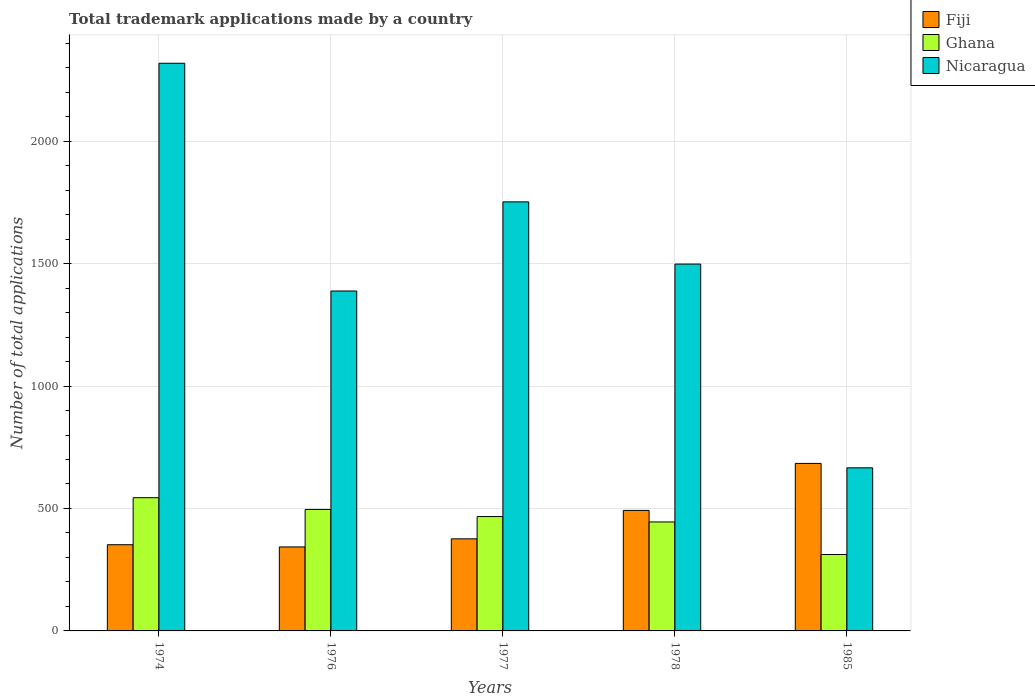How many groups of bars are there?
Ensure brevity in your answer.  5. Are the number of bars on each tick of the X-axis equal?
Offer a terse response. Yes. How many bars are there on the 4th tick from the left?
Ensure brevity in your answer.  3. What is the label of the 2nd group of bars from the left?
Offer a terse response. 1976. What is the number of applications made by in Ghana in 1974?
Your response must be concise. 544. Across all years, what is the maximum number of applications made by in Ghana?
Offer a terse response. 544. Across all years, what is the minimum number of applications made by in Ghana?
Provide a succinct answer. 312. In which year was the number of applications made by in Nicaragua maximum?
Offer a terse response. 1974. What is the total number of applications made by in Ghana in the graph?
Your answer should be compact. 2264. What is the difference between the number of applications made by in Nicaragua in 1974 and that in 1977?
Your response must be concise. 566. What is the difference between the number of applications made by in Fiji in 1976 and the number of applications made by in Ghana in 1974?
Your response must be concise. -201. What is the average number of applications made by in Fiji per year?
Offer a very short reply. 449.4. In the year 1977, what is the difference between the number of applications made by in Ghana and number of applications made by in Fiji?
Provide a short and direct response. 91. In how many years, is the number of applications made by in Nicaragua greater than 1700?
Offer a very short reply. 2. What is the ratio of the number of applications made by in Fiji in 1974 to that in 1985?
Offer a terse response. 0.51. Is the number of applications made by in Fiji in 1974 less than that in 1977?
Give a very brief answer. Yes. Is the difference between the number of applications made by in Ghana in 1976 and 1985 greater than the difference between the number of applications made by in Fiji in 1976 and 1985?
Offer a very short reply. Yes. What is the difference between the highest and the second highest number of applications made by in Ghana?
Offer a very short reply. 48. What is the difference between the highest and the lowest number of applications made by in Fiji?
Your answer should be very brief. 341. In how many years, is the number of applications made by in Nicaragua greater than the average number of applications made by in Nicaragua taken over all years?
Make the answer very short. 2. Is the sum of the number of applications made by in Ghana in 1977 and 1985 greater than the maximum number of applications made by in Fiji across all years?
Provide a succinct answer. Yes. What does the 1st bar from the right in 1977 represents?
Provide a succinct answer. Nicaragua. How many years are there in the graph?
Offer a terse response. 5. What is the difference between two consecutive major ticks on the Y-axis?
Make the answer very short. 500. Does the graph contain any zero values?
Ensure brevity in your answer.  No. How many legend labels are there?
Make the answer very short. 3. What is the title of the graph?
Your response must be concise. Total trademark applications made by a country. What is the label or title of the Y-axis?
Your answer should be very brief. Number of total applications. What is the Number of total applications in Fiji in 1974?
Your answer should be very brief. 352. What is the Number of total applications of Ghana in 1974?
Your answer should be compact. 544. What is the Number of total applications of Nicaragua in 1974?
Your answer should be compact. 2318. What is the Number of total applications of Fiji in 1976?
Your answer should be very brief. 343. What is the Number of total applications of Ghana in 1976?
Provide a short and direct response. 496. What is the Number of total applications of Nicaragua in 1976?
Offer a very short reply. 1388. What is the Number of total applications of Fiji in 1977?
Provide a succinct answer. 376. What is the Number of total applications of Ghana in 1977?
Give a very brief answer. 467. What is the Number of total applications in Nicaragua in 1977?
Offer a terse response. 1752. What is the Number of total applications of Fiji in 1978?
Provide a short and direct response. 492. What is the Number of total applications of Ghana in 1978?
Your answer should be compact. 445. What is the Number of total applications of Nicaragua in 1978?
Offer a very short reply. 1498. What is the Number of total applications in Fiji in 1985?
Provide a short and direct response. 684. What is the Number of total applications of Ghana in 1985?
Keep it short and to the point. 312. What is the Number of total applications in Nicaragua in 1985?
Provide a succinct answer. 666. Across all years, what is the maximum Number of total applications in Fiji?
Provide a short and direct response. 684. Across all years, what is the maximum Number of total applications in Ghana?
Offer a terse response. 544. Across all years, what is the maximum Number of total applications of Nicaragua?
Offer a very short reply. 2318. Across all years, what is the minimum Number of total applications in Fiji?
Your response must be concise. 343. Across all years, what is the minimum Number of total applications of Ghana?
Your response must be concise. 312. Across all years, what is the minimum Number of total applications in Nicaragua?
Your response must be concise. 666. What is the total Number of total applications of Fiji in the graph?
Your answer should be very brief. 2247. What is the total Number of total applications in Ghana in the graph?
Your answer should be very brief. 2264. What is the total Number of total applications in Nicaragua in the graph?
Your answer should be compact. 7622. What is the difference between the Number of total applications of Ghana in 1974 and that in 1976?
Ensure brevity in your answer.  48. What is the difference between the Number of total applications of Nicaragua in 1974 and that in 1976?
Your answer should be very brief. 930. What is the difference between the Number of total applications in Fiji in 1974 and that in 1977?
Offer a terse response. -24. What is the difference between the Number of total applications of Nicaragua in 1974 and that in 1977?
Ensure brevity in your answer.  566. What is the difference between the Number of total applications of Fiji in 1974 and that in 1978?
Give a very brief answer. -140. What is the difference between the Number of total applications of Ghana in 1974 and that in 1978?
Ensure brevity in your answer.  99. What is the difference between the Number of total applications of Nicaragua in 1974 and that in 1978?
Offer a very short reply. 820. What is the difference between the Number of total applications of Fiji in 1974 and that in 1985?
Your answer should be very brief. -332. What is the difference between the Number of total applications of Ghana in 1974 and that in 1985?
Provide a short and direct response. 232. What is the difference between the Number of total applications of Nicaragua in 1974 and that in 1985?
Offer a very short reply. 1652. What is the difference between the Number of total applications of Fiji in 1976 and that in 1977?
Provide a succinct answer. -33. What is the difference between the Number of total applications in Ghana in 1976 and that in 1977?
Ensure brevity in your answer.  29. What is the difference between the Number of total applications of Nicaragua in 1976 and that in 1977?
Ensure brevity in your answer.  -364. What is the difference between the Number of total applications in Fiji in 1976 and that in 1978?
Offer a very short reply. -149. What is the difference between the Number of total applications of Nicaragua in 1976 and that in 1978?
Your answer should be compact. -110. What is the difference between the Number of total applications of Fiji in 1976 and that in 1985?
Your answer should be compact. -341. What is the difference between the Number of total applications of Ghana in 1976 and that in 1985?
Your response must be concise. 184. What is the difference between the Number of total applications in Nicaragua in 1976 and that in 1985?
Keep it short and to the point. 722. What is the difference between the Number of total applications of Fiji in 1977 and that in 1978?
Offer a very short reply. -116. What is the difference between the Number of total applications in Nicaragua in 1977 and that in 1978?
Provide a succinct answer. 254. What is the difference between the Number of total applications of Fiji in 1977 and that in 1985?
Provide a short and direct response. -308. What is the difference between the Number of total applications of Ghana in 1977 and that in 1985?
Ensure brevity in your answer.  155. What is the difference between the Number of total applications of Nicaragua in 1977 and that in 1985?
Make the answer very short. 1086. What is the difference between the Number of total applications in Fiji in 1978 and that in 1985?
Keep it short and to the point. -192. What is the difference between the Number of total applications of Ghana in 1978 and that in 1985?
Provide a short and direct response. 133. What is the difference between the Number of total applications in Nicaragua in 1978 and that in 1985?
Provide a succinct answer. 832. What is the difference between the Number of total applications of Fiji in 1974 and the Number of total applications of Ghana in 1976?
Offer a terse response. -144. What is the difference between the Number of total applications of Fiji in 1974 and the Number of total applications of Nicaragua in 1976?
Make the answer very short. -1036. What is the difference between the Number of total applications of Ghana in 1974 and the Number of total applications of Nicaragua in 1976?
Keep it short and to the point. -844. What is the difference between the Number of total applications in Fiji in 1974 and the Number of total applications in Ghana in 1977?
Your answer should be compact. -115. What is the difference between the Number of total applications of Fiji in 1974 and the Number of total applications of Nicaragua in 1977?
Your answer should be compact. -1400. What is the difference between the Number of total applications of Ghana in 1974 and the Number of total applications of Nicaragua in 1977?
Provide a succinct answer. -1208. What is the difference between the Number of total applications of Fiji in 1974 and the Number of total applications of Ghana in 1978?
Your response must be concise. -93. What is the difference between the Number of total applications of Fiji in 1974 and the Number of total applications of Nicaragua in 1978?
Offer a very short reply. -1146. What is the difference between the Number of total applications of Ghana in 1974 and the Number of total applications of Nicaragua in 1978?
Give a very brief answer. -954. What is the difference between the Number of total applications in Fiji in 1974 and the Number of total applications in Ghana in 1985?
Your answer should be very brief. 40. What is the difference between the Number of total applications of Fiji in 1974 and the Number of total applications of Nicaragua in 1985?
Your answer should be very brief. -314. What is the difference between the Number of total applications in Ghana in 1974 and the Number of total applications in Nicaragua in 1985?
Provide a succinct answer. -122. What is the difference between the Number of total applications in Fiji in 1976 and the Number of total applications in Ghana in 1977?
Keep it short and to the point. -124. What is the difference between the Number of total applications in Fiji in 1976 and the Number of total applications in Nicaragua in 1977?
Your response must be concise. -1409. What is the difference between the Number of total applications of Ghana in 1976 and the Number of total applications of Nicaragua in 1977?
Offer a very short reply. -1256. What is the difference between the Number of total applications of Fiji in 1976 and the Number of total applications of Ghana in 1978?
Provide a succinct answer. -102. What is the difference between the Number of total applications in Fiji in 1976 and the Number of total applications in Nicaragua in 1978?
Your response must be concise. -1155. What is the difference between the Number of total applications in Ghana in 1976 and the Number of total applications in Nicaragua in 1978?
Make the answer very short. -1002. What is the difference between the Number of total applications in Fiji in 1976 and the Number of total applications in Nicaragua in 1985?
Provide a short and direct response. -323. What is the difference between the Number of total applications in Ghana in 1976 and the Number of total applications in Nicaragua in 1985?
Your response must be concise. -170. What is the difference between the Number of total applications in Fiji in 1977 and the Number of total applications in Ghana in 1978?
Make the answer very short. -69. What is the difference between the Number of total applications in Fiji in 1977 and the Number of total applications in Nicaragua in 1978?
Give a very brief answer. -1122. What is the difference between the Number of total applications in Ghana in 1977 and the Number of total applications in Nicaragua in 1978?
Your answer should be very brief. -1031. What is the difference between the Number of total applications of Fiji in 1977 and the Number of total applications of Ghana in 1985?
Your answer should be compact. 64. What is the difference between the Number of total applications of Fiji in 1977 and the Number of total applications of Nicaragua in 1985?
Offer a terse response. -290. What is the difference between the Number of total applications of Ghana in 1977 and the Number of total applications of Nicaragua in 1985?
Provide a succinct answer. -199. What is the difference between the Number of total applications in Fiji in 1978 and the Number of total applications in Ghana in 1985?
Your answer should be compact. 180. What is the difference between the Number of total applications in Fiji in 1978 and the Number of total applications in Nicaragua in 1985?
Your answer should be very brief. -174. What is the difference between the Number of total applications in Ghana in 1978 and the Number of total applications in Nicaragua in 1985?
Offer a terse response. -221. What is the average Number of total applications in Fiji per year?
Your response must be concise. 449.4. What is the average Number of total applications of Ghana per year?
Provide a succinct answer. 452.8. What is the average Number of total applications of Nicaragua per year?
Your answer should be very brief. 1524.4. In the year 1974, what is the difference between the Number of total applications in Fiji and Number of total applications in Ghana?
Provide a succinct answer. -192. In the year 1974, what is the difference between the Number of total applications in Fiji and Number of total applications in Nicaragua?
Your response must be concise. -1966. In the year 1974, what is the difference between the Number of total applications of Ghana and Number of total applications of Nicaragua?
Your answer should be very brief. -1774. In the year 1976, what is the difference between the Number of total applications of Fiji and Number of total applications of Ghana?
Keep it short and to the point. -153. In the year 1976, what is the difference between the Number of total applications of Fiji and Number of total applications of Nicaragua?
Keep it short and to the point. -1045. In the year 1976, what is the difference between the Number of total applications in Ghana and Number of total applications in Nicaragua?
Offer a terse response. -892. In the year 1977, what is the difference between the Number of total applications in Fiji and Number of total applications in Ghana?
Give a very brief answer. -91. In the year 1977, what is the difference between the Number of total applications in Fiji and Number of total applications in Nicaragua?
Give a very brief answer. -1376. In the year 1977, what is the difference between the Number of total applications of Ghana and Number of total applications of Nicaragua?
Ensure brevity in your answer.  -1285. In the year 1978, what is the difference between the Number of total applications in Fiji and Number of total applications in Ghana?
Provide a succinct answer. 47. In the year 1978, what is the difference between the Number of total applications in Fiji and Number of total applications in Nicaragua?
Provide a short and direct response. -1006. In the year 1978, what is the difference between the Number of total applications of Ghana and Number of total applications of Nicaragua?
Your answer should be very brief. -1053. In the year 1985, what is the difference between the Number of total applications of Fiji and Number of total applications of Ghana?
Provide a short and direct response. 372. In the year 1985, what is the difference between the Number of total applications of Ghana and Number of total applications of Nicaragua?
Keep it short and to the point. -354. What is the ratio of the Number of total applications of Fiji in 1974 to that in 1976?
Make the answer very short. 1.03. What is the ratio of the Number of total applications of Ghana in 1974 to that in 1976?
Provide a short and direct response. 1.1. What is the ratio of the Number of total applications in Nicaragua in 1974 to that in 1976?
Your response must be concise. 1.67. What is the ratio of the Number of total applications in Fiji in 1974 to that in 1977?
Offer a very short reply. 0.94. What is the ratio of the Number of total applications in Ghana in 1974 to that in 1977?
Make the answer very short. 1.16. What is the ratio of the Number of total applications of Nicaragua in 1974 to that in 1977?
Provide a short and direct response. 1.32. What is the ratio of the Number of total applications in Fiji in 1974 to that in 1978?
Ensure brevity in your answer.  0.72. What is the ratio of the Number of total applications of Ghana in 1974 to that in 1978?
Provide a short and direct response. 1.22. What is the ratio of the Number of total applications in Nicaragua in 1974 to that in 1978?
Provide a short and direct response. 1.55. What is the ratio of the Number of total applications in Fiji in 1974 to that in 1985?
Ensure brevity in your answer.  0.51. What is the ratio of the Number of total applications in Ghana in 1974 to that in 1985?
Provide a short and direct response. 1.74. What is the ratio of the Number of total applications in Nicaragua in 1974 to that in 1985?
Your response must be concise. 3.48. What is the ratio of the Number of total applications of Fiji in 1976 to that in 1977?
Make the answer very short. 0.91. What is the ratio of the Number of total applications in Ghana in 1976 to that in 1977?
Give a very brief answer. 1.06. What is the ratio of the Number of total applications in Nicaragua in 1976 to that in 1977?
Your answer should be very brief. 0.79. What is the ratio of the Number of total applications of Fiji in 1976 to that in 1978?
Keep it short and to the point. 0.7. What is the ratio of the Number of total applications in Ghana in 1976 to that in 1978?
Your response must be concise. 1.11. What is the ratio of the Number of total applications in Nicaragua in 1976 to that in 1978?
Offer a very short reply. 0.93. What is the ratio of the Number of total applications in Fiji in 1976 to that in 1985?
Provide a succinct answer. 0.5. What is the ratio of the Number of total applications in Ghana in 1976 to that in 1985?
Give a very brief answer. 1.59. What is the ratio of the Number of total applications in Nicaragua in 1976 to that in 1985?
Offer a terse response. 2.08. What is the ratio of the Number of total applications in Fiji in 1977 to that in 1978?
Your response must be concise. 0.76. What is the ratio of the Number of total applications of Ghana in 1977 to that in 1978?
Provide a short and direct response. 1.05. What is the ratio of the Number of total applications in Nicaragua in 1977 to that in 1978?
Offer a very short reply. 1.17. What is the ratio of the Number of total applications of Fiji in 1977 to that in 1985?
Keep it short and to the point. 0.55. What is the ratio of the Number of total applications of Ghana in 1977 to that in 1985?
Your answer should be compact. 1.5. What is the ratio of the Number of total applications of Nicaragua in 1977 to that in 1985?
Your answer should be very brief. 2.63. What is the ratio of the Number of total applications in Fiji in 1978 to that in 1985?
Your response must be concise. 0.72. What is the ratio of the Number of total applications in Ghana in 1978 to that in 1985?
Keep it short and to the point. 1.43. What is the ratio of the Number of total applications in Nicaragua in 1978 to that in 1985?
Your response must be concise. 2.25. What is the difference between the highest and the second highest Number of total applications in Fiji?
Give a very brief answer. 192. What is the difference between the highest and the second highest Number of total applications in Nicaragua?
Your answer should be very brief. 566. What is the difference between the highest and the lowest Number of total applications of Fiji?
Provide a succinct answer. 341. What is the difference between the highest and the lowest Number of total applications in Ghana?
Ensure brevity in your answer.  232. What is the difference between the highest and the lowest Number of total applications of Nicaragua?
Offer a terse response. 1652. 